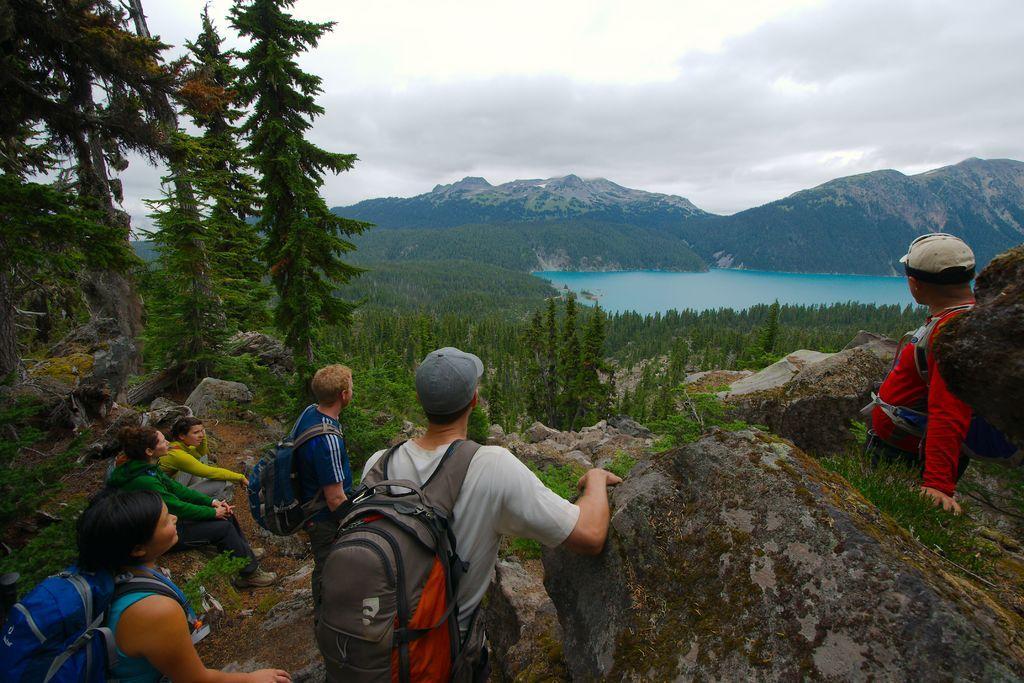Could you give a brief overview of what you see in this image? This is the picture of a place where we have some people wearing backpacks on the rocks and around there are some trees, plants, mountains and a lake. 